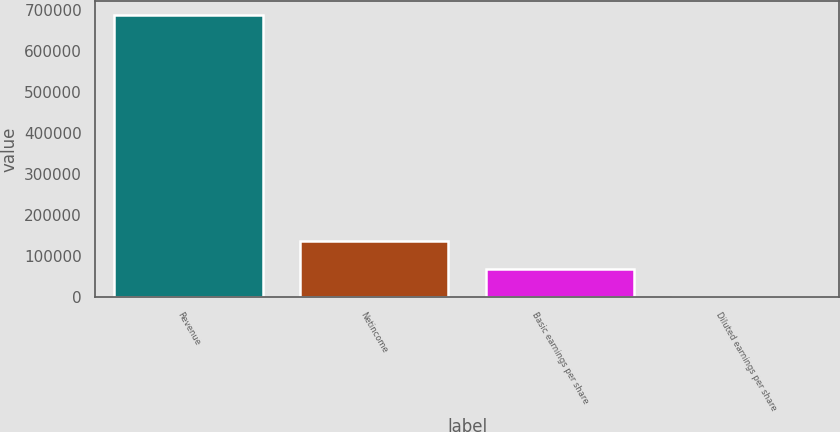Convert chart. <chart><loc_0><loc_0><loc_500><loc_500><bar_chart><fcel>Revenue<fcel>Netincome<fcel>Basic earnings per share<fcel>Diluted earnings per share<nl><fcel>688814<fcel>137764<fcel>68882.9<fcel>1.69<nl></chart> 